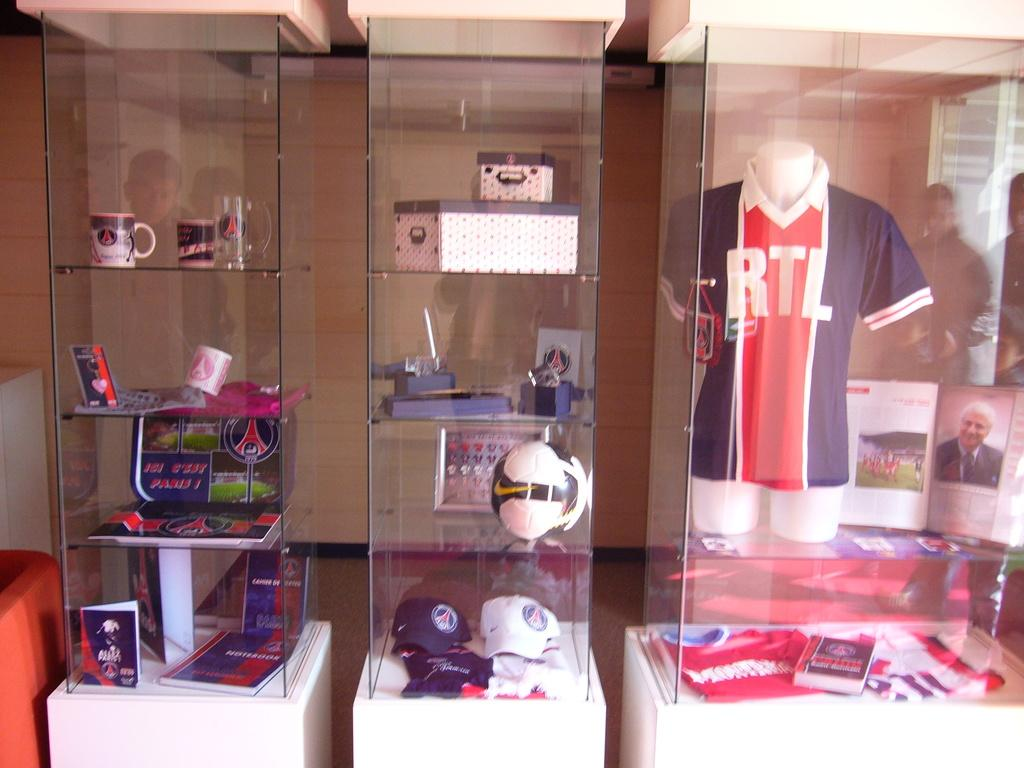<image>
Share a concise interpretation of the image provided. Sports items behind glass including a jersey with RTL 